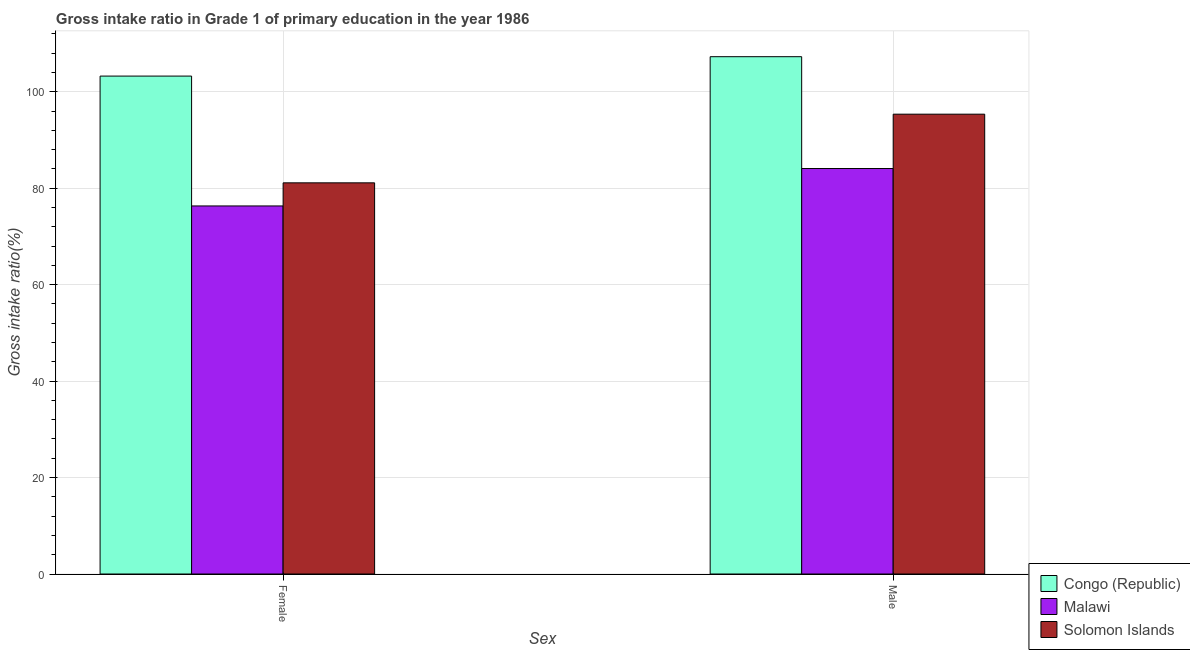Are the number of bars on each tick of the X-axis equal?
Make the answer very short. Yes. How many bars are there on the 1st tick from the right?
Ensure brevity in your answer.  3. What is the gross intake ratio(male) in Congo (Republic)?
Give a very brief answer. 107.28. Across all countries, what is the maximum gross intake ratio(male)?
Give a very brief answer. 107.28. Across all countries, what is the minimum gross intake ratio(male)?
Your answer should be compact. 84.09. In which country was the gross intake ratio(female) maximum?
Keep it short and to the point. Congo (Republic). In which country was the gross intake ratio(male) minimum?
Keep it short and to the point. Malawi. What is the total gross intake ratio(male) in the graph?
Ensure brevity in your answer.  286.72. What is the difference between the gross intake ratio(female) in Solomon Islands and that in Congo (Republic)?
Your answer should be very brief. -22.14. What is the difference between the gross intake ratio(male) in Malawi and the gross intake ratio(female) in Solomon Islands?
Keep it short and to the point. 2.97. What is the average gross intake ratio(male) per country?
Give a very brief answer. 95.57. What is the difference between the gross intake ratio(male) and gross intake ratio(female) in Malawi?
Make the answer very short. 7.76. In how many countries, is the gross intake ratio(male) greater than 60 %?
Your answer should be compact. 3. What is the ratio of the gross intake ratio(female) in Malawi to that in Congo (Republic)?
Offer a very short reply. 0.74. In how many countries, is the gross intake ratio(female) greater than the average gross intake ratio(female) taken over all countries?
Keep it short and to the point. 1. What does the 3rd bar from the left in Male represents?
Keep it short and to the point. Solomon Islands. What does the 3rd bar from the right in Female represents?
Ensure brevity in your answer.  Congo (Republic). Are all the bars in the graph horizontal?
Offer a terse response. No. How many countries are there in the graph?
Offer a very short reply. 3. What is the difference between two consecutive major ticks on the Y-axis?
Your answer should be compact. 20. Does the graph contain any zero values?
Offer a very short reply. No. What is the title of the graph?
Provide a short and direct response. Gross intake ratio in Grade 1 of primary education in the year 1986. What is the label or title of the X-axis?
Ensure brevity in your answer.  Sex. What is the label or title of the Y-axis?
Make the answer very short. Gross intake ratio(%). What is the Gross intake ratio(%) in Congo (Republic) in Female?
Ensure brevity in your answer.  103.26. What is the Gross intake ratio(%) of Malawi in Female?
Your answer should be compact. 76.33. What is the Gross intake ratio(%) in Solomon Islands in Female?
Make the answer very short. 81.12. What is the Gross intake ratio(%) of Congo (Republic) in Male?
Offer a terse response. 107.28. What is the Gross intake ratio(%) of Malawi in Male?
Your answer should be compact. 84.09. What is the Gross intake ratio(%) of Solomon Islands in Male?
Keep it short and to the point. 95.36. Across all Sex, what is the maximum Gross intake ratio(%) in Congo (Republic)?
Offer a terse response. 107.28. Across all Sex, what is the maximum Gross intake ratio(%) in Malawi?
Ensure brevity in your answer.  84.09. Across all Sex, what is the maximum Gross intake ratio(%) of Solomon Islands?
Ensure brevity in your answer.  95.36. Across all Sex, what is the minimum Gross intake ratio(%) in Congo (Republic)?
Your answer should be very brief. 103.26. Across all Sex, what is the minimum Gross intake ratio(%) of Malawi?
Provide a succinct answer. 76.33. Across all Sex, what is the minimum Gross intake ratio(%) of Solomon Islands?
Provide a succinct answer. 81.12. What is the total Gross intake ratio(%) in Congo (Republic) in the graph?
Your response must be concise. 210.54. What is the total Gross intake ratio(%) of Malawi in the graph?
Your answer should be compact. 160.41. What is the total Gross intake ratio(%) of Solomon Islands in the graph?
Ensure brevity in your answer.  176.48. What is the difference between the Gross intake ratio(%) of Congo (Republic) in Female and that in Male?
Offer a very short reply. -4.02. What is the difference between the Gross intake ratio(%) in Malawi in Female and that in Male?
Ensure brevity in your answer.  -7.76. What is the difference between the Gross intake ratio(%) of Solomon Islands in Female and that in Male?
Offer a terse response. -14.24. What is the difference between the Gross intake ratio(%) in Congo (Republic) in Female and the Gross intake ratio(%) in Malawi in Male?
Keep it short and to the point. 19.17. What is the difference between the Gross intake ratio(%) of Congo (Republic) in Female and the Gross intake ratio(%) of Solomon Islands in Male?
Your response must be concise. 7.9. What is the difference between the Gross intake ratio(%) in Malawi in Female and the Gross intake ratio(%) in Solomon Islands in Male?
Your response must be concise. -19.03. What is the average Gross intake ratio(%) of Congo (Republic) per Sex?
Provide a succinct answer. 105.27. What is the average Gross intake ratio(%) in Malawi per Sex?
Offer a very short reply. 80.21. What is the average Gross intake ratio(%) in Solomon Islands per Sex?
Keep it short and to the point. 88.24. What is the difference between the Gross intake ratio(%) in Congo (Republic) and Gross intake ratio(%) in Malawi in Female?
Offer a terse response. 26.93. What is the difference between the Gross intake ratio(%) in Congo (Republic) and Gross intake ratio(%) in Solomon Islands in Female?
Your answer should be very brief. 22.14. What is the difference between the Gross intake ratio(%) in Malawi and Gross intake ratio(%) in Solomon Islands in Female?
Provide a succinct answer. -4.79. What is the difference between the Gross intake ratio(%) of Congo (Republic) and Gross intake ratio(%) of Malawi in Male?
Keep it short and to the point. 23.19. What is the difference between the Gross intake ratio(%) in Congo (Republic) and Gross intake ratio(%) in Solomon Islands in Male?
Ensure brevity in your answer.  11.92. What is the difference between the Gross intake ratio(%) of Malawi and Gross intake ratio(%) of Solomon Islands in Male?
Provide a short and direct response. -11.27. What is the ratio of the Gross intake ratio(%) of Congo (Republic) in Female to that in Male?
Your answer should be very brief. 0.96. What is the ratio of the Gross intake ratio(%) of Malawi in Female to that in Male?
Ensure brevity in your answer.  0.91. What is the ratio of the Gross intake ratio(%) of Solomon Islands in Female to that in Male?
Your answer should be compact. 0.85. What is the difference between the highest and the second highest Gross intake ratio(%) in Congo (Republic)?
Provide a short and direct response. 4.02. What is the difference between the highest and the second highest Gross intake ratio(%) of Malawi?
Offer a terse response. 7.76. What is the difference between the highest and the second highest Gross intake ratio(%) in Solomon Islands?
Make the answer very short. 14.24. What is the difference between the highest and the lowest Gross intake ratio(%) in Congo (Republic)?
Offer a terse response. 4.02. What is the difference between the highest and the lowest Gross intake ratio(%) of Malawi?
Your answer should be very brief. 7.76. What is the difference between the highest and the lowest Gross intake ratio(%) in Solomon Islands?
Give a very brief answer. 14.24. 